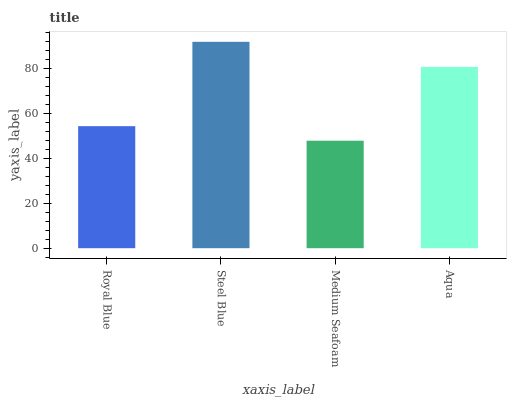Is Medium Seafoam the minimum?
Answer yes or no. Yes. Is Steel Blue the maximum?
Answer yes or no. Yes. Is Steel Blue the minimum?
Answer yes or no. No. Is Medium Seafoam the maximum?
Answer yes or no. No. Is Steel Blue greater than Medium Seafoam?
Answer yes or no. Yes. Is Medium Seafoam less than Steel Blue?
Answer yes or no. Yes. Is Medium Seafoam greater than Steel Blue?
Answer yes or no. No. Is Steel Blue less than Medium Seafoam?
Answer yes or no. No. Is Aqua the high median?
Answer yes or no. Yes. Is Royal Blue the low median?
Answer yes or no. Yes. Is Royal Blue the high median?
Answer yes or no. No. Is Medium Seafoam the low median?
Answer yes or no. No. 